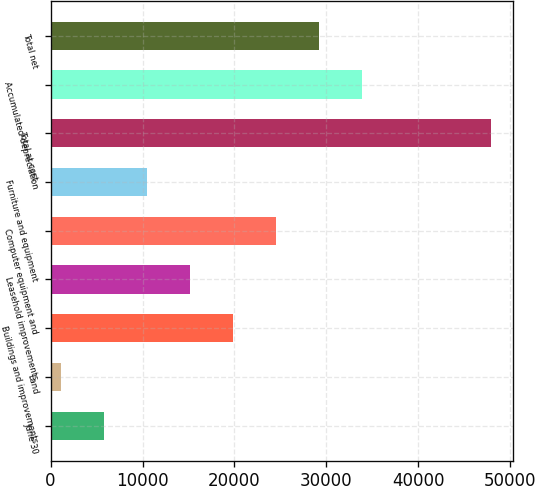<chart> <loc_0><loc_0><loc_500><loc_500><bar_chart><fcel>June 30<fcel>Land<fcel>Buildings and improvements<fcel>Leasehold improvements<fcel>Computer equipment and<fcel>Furniture and equipment<fcel>Total at cost<fcel>Accumulated depreciation<fcel>Total net<nl><fcel>5787.6<fcel>1107<fcel>19829.4<fcel>15148.8<fcel>24510<fcel>10468.2<fcel>47913<fcel>33871.2<fcel>29190.6<nl></chart> 